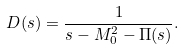Convert formula to latex. <formula><loc_0><loc_0><loc_500><loc_500>D ( s ) = \frac { 1 } { s - M _ { 0 } ^ { 2 } - \Pi ( s ) } .</formula> 